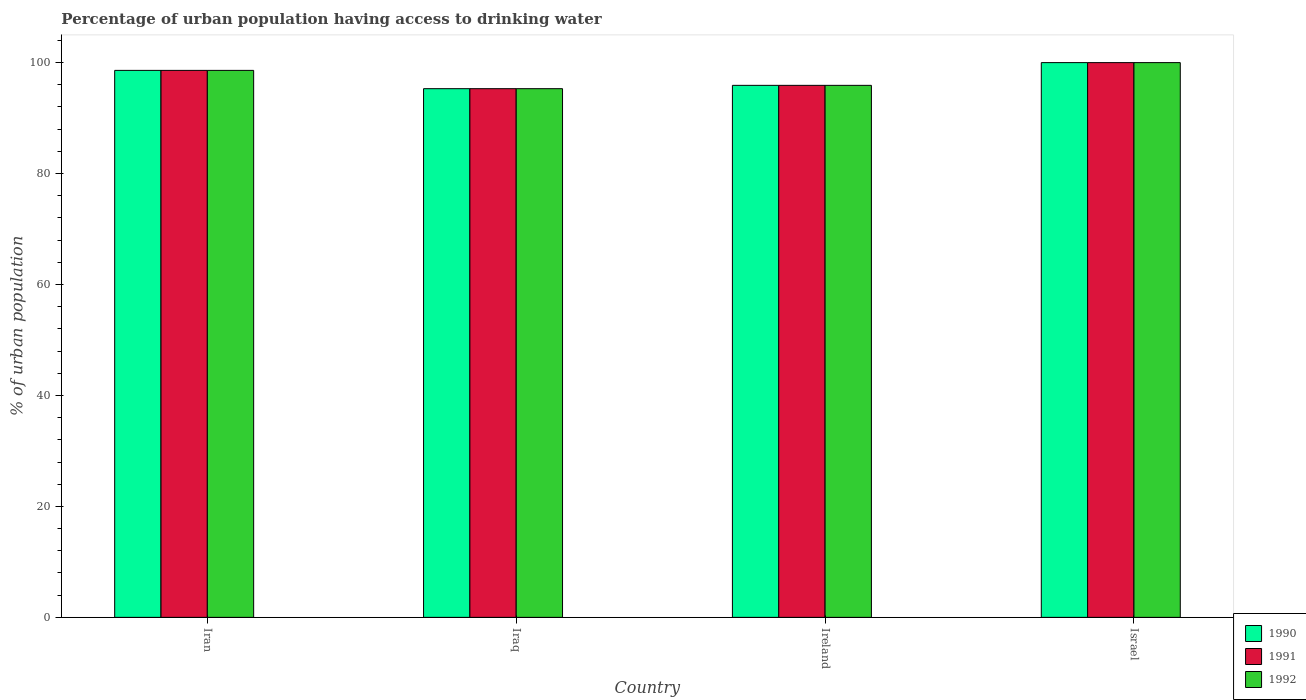How many different coloured bars are there?
Give a very brief answer. 3. How many groups of bars are there?
Your answer should be compact. 4. Are the number of bars per tick equal to the number of legend labels?
Ensure brevity in your answer.  Yes. Are the number of bars on each tick of the X-axis equal?
Offer a very short reply. Yes. How many bars are there on the 1st tick from the left?
Your response must be concise. 3. How many bars are there on the 4th tick from the right?
Offer a terse response. 3. What is the label of the 1st group of bars from the left?
Your response must be concise. Iran. In how many cases, is the number of bars for a given country not equal to the number of legend labels?
Make the answer very short. 0. What is the percentage of urban population having access to drinking water in 1990 in Ireland?
Your answer should be compact. 95.9. Across all countries, what is the maximum percentage of urban population having access to drinking water in 1990?
Make the answer very short. 100. Across all countries, what is the minimum percentage of urban population having access to drinking water in 1992?
Your answer should be compact. 95.3. In which country was the percentage of urban population having access to drinking water in 1991 minimum?
Provide a short and direct response. Iraq. What is the total percentage of urban population having access to drinking water in 1990 in the graph?
Provide a short and direct response. 389.8. What is the difference between the percentage of urban population having access to drinking water in 1990 in Ireland and that in Israel?
Make the answer very short. -4.1. What is the difference between the percentage of urban population having access to drinking water in 1990 in Iran and the percentage of urban population having access to drinking water in 1991 in Israel?
Provide a succinct answer. -1.4. What is the average percentage of urban population having access to drinking water in 1990 per country?
Offer a terse response. 97.45. What is the difference between the percentage of urban population having access to drinking water of/in 1992 and percentage of urban population having access to drinking water of/in 1991 in Israel?
Offer a terse response. 0. What is the ratio of the percentage of urban population having access to drinking water in 1990 in Iran to that in Ireland?
Offer a terse response. 1.03. Is the difference between the percentage of urban population having access to drinking water in 1992 in Iran and Israel greater than the difference between the percentage of urban population having access to drinking water in 1991 in Iran and Israel?
Make the answer very short. No. What is the difference between the highest and the second highest percentage of urban population having access to drinking water in 1992?
Ensure brevity in your answer.  -1.4. What is the difference between the highest and the lowest percentage of urban population having access to drinking water in 1992?
Provide a short and direct response. 4.7. In how many countries, is the percentage of urban population having access to drinking water in 1992 greater than the average percentage of urban population having access to drinking water in 1992 taken over all countries?
Your answer should be compact. 2. What does the 1st bar from the left in Iraq represents?
Make the answer very short. 1990. What does the 1st bar from the right in Iraq represents?
Keep it short and to the point. 1992. How many bars are there?
Give a very brief answer. 12. Are all the bars in the graph horizontal?
Your answer should be very brief. No. How many countries are there in the graph?
Provide a succinct answer. 4. Does the graph contain any zero values?
Offer a very short reply. No. Does the graph contain grids?
Make the answer very short. No. Where does the legend appear in the graph?
Offer a very short reply. Bottom right. What is the title of the graph?
Ensure brevity in your answer.  Percentage of urban population having access to drinking water. Does "2003" appear as one of the legend labels in the graph?
Ensure brevity in your answer.  No. What is the label or title of the X-axis?
Your answer should be compact. Country. What is the label or title of the Y-axis?
Your answer should be compact. % of urban population. What is the % of urban population in 1990 in Iran?
Provide a succinct answer. 98.6. What is the % of urban population of 1991 in Iran?
Your answer should be very brief. 98.6. What is the % of urban population of 1992 in Iran?
Keep it short and to the point. 98.6. What is the % of urban population in 1990 in Iraq?
Provide a short and direct response. 95.3. What is the % of urban population in 1991 in Iraq?
Offer a terse response. 95.3. What is the % of urban population of 1992 in Iraq?
Your answer should be very brief. 95.3. What is the % of urban population of 1990 in Ireland?
Provide a short and direct response. 95.9. What is the % of urban population of 1991 in Ireland?
Give a very brief answer. 95.9. What is the % of urban population in 1992 in Ireland?
Keep it short and to the point. 95.9. What is the % of urban population in 1990 in Israel?
Keep it short and to the point. 100. Across all countries, what is the maximum % of urban population in 1990?
Offer a terse response. 100. Across all countries, what is the minimum % of urban population in 1990?
Your answer should be compact. 95.3. Across all countries, what is the minimum % of urban population of 1991?
Your answer should be compact. 95.3. Across all countries, what is the minimum % of urban population in 1992?
Make the answer very short. 95.3. What is the total % of urban population in 1990 in the graph?
Your response must be concise. 389.8. What is the total % of urban population in 1991 in the graph?
Make the answer very short. 389.8. What is the total % of urban population in 1992 in the graph?
Offer a terse response. 389.8. What is the difference between the % of urban population in 1991 in Iran and that in Iraq?
Provide a succinct answer. 3.3. What is the difference between the % of urban population in 1992 in Iran and that in Ireland?
Give a very brief answer. 2.7. What is the difference between the % of urban population of 1990 in Iraq and that in Ireland?
Ensure brevity in your answer.  -0.6. What is the difference between the % of urban population in 1992 in Iraq and that in Ireland?
Your answer should be compact. -0.6. What is the difference between the % of urban population in 1990 in Iraq and that in Israel?
Your answer should be very brief. -4.7. What is the difference between the % of urban population of 1991 in Iraq and that in Israel?
Keep it short and to the point. -4.7. What is the difference between the % of urban population in 1990 in Ireland and that in Israel?
Ensure brevity in your answer.  -4.1. What is the difference between the % of urban population in 1992 in Ireland and that in Israel?
Provide a short and direct response. -4.1. What is the difference between the % of urban population in 1990 in Iran and the % of urban population in 1991 in Iraq?
Make the answer very short. 3.3. What is the difference between the % of urban population in 1991 in Iran and the % of urban population in 1992 in Iraq?
Provide a short and direct response. 3.3. What is the difference between the % of urban population in 1990 in Iran and the % of urban population in 1991 in Ireland?
Provide a short and direct response. 2.7. What is the difference between the % of urban population in 1990 in Iran and the % of urban population in 1992 in Ireland?
Your answer should be compact. 2.7. What is the difference between the % of urban population in 1991 in Iran and the % of urban population in 1992 in Israel?
Make the answer very short. -1.4. What is the difference between the % of urban population in 1990 in Iraq and the % of urban population in 1991 in Ireland?
Your response must be concise. -0.6. What is the difference between the % of urban population in 1990 in Iraq and the % of urban population in 1992 in Ireland?
Ensure brevity in your answer.  -0.6. What is the difference between the % of urban population in 1991 in Iraq and the % of urban population in 1992 in Ireland?
Ensure brevity in your answer.  -0.6. What is the difference between the % of urban population in 1990 in Iraq and the % of urban population in 1991 in Israel?
Offer a very short reply. -4.7. What is the difference between the % of urban population in 1991 in Iraq and the % of urban population in 1992 in Israel?
Provide a short and direct response. -4.7. What is the difference between the % of urban population in 1990 in Ireland and the % of urban population in 1991 in Israel?
Your response must be concise. -4.1. What is the difference between the % of urban population in 1990 in Ireland and the % of urban population in 1992 in Israel?
Your response must be concise. -4.1. What is the difference between the % of urban population of 1991 in Ireland and the % of urban population of 1992 in Israel?
Offer a very short reply. -4.1. What is the average % of urban population of 1990 per country?
Keep it short and to the point. 97.45. What is the average % of urban population of 1991 per country?
Provide a succinct answer. 97.45. What is the average % of urban population of 1992 per country?
Provide a succinct answer. 97.45. What is the difference between the % of urban population of 1990 and % of urban population of 1992 in Iran?
Ensure brevity in your answer.  0. What is the difference between the % of urban population in 1991 and % of urban population in 1992 in Iran?
Your answer should be compact. 0. What is the difference between the % of urban population of 1990 and % of urban population of 1991 in Iraq?
Offer a terse response. 0. What is the difference between the % of urban population of 1990 and % of urban population of 1991 in Ireland?
Provide a short and direct response. 0. What is the difference between the % of urban population of 1990 and % of urban population of 1992 in Ireland?
Provide a short and direct response. 0. What is the difference between the % of urban population of 1991 and % of urban population of 1992 in Ireland?
Provide a succinct answer. 0. What is the difference between the % of urban population of 1990 and % of urban population of 1991 in Israel?
Offer a terse response. 0. What is the difference between the % of urban population of 1991 and % of urban population of 1992 in Israel?
Your response must be concise. 0. What is the ratio of the % of urban population of 1990 in Iran to that in Iraq?
Your response must be concise. 1.03. What is the ratio of the % of urban population of 1991 in Iran to that in Iraq?
Make the answer very short. 1.03. What is the ratio of the % of urban population in 1992 in Iran to that in Iraq?
Offer a very short reply. 1.03. What is the ratio of the % of urban population in 1990 in Iran to that in Ireland?
Provide a succinct answer. 1.03. What is the ratio of the % of urban population in 1991 in Iran to that in Ireland?
Your answer should be very brief. 1.03. What is the ratio of the % of urban population of 1992 in Iran to that in Ireland?
Provide a short and direct response. 1.03. What is the ratio of the % of urban population in 1990 in Iran to that in Israel?
Offer a terse response. 0.99. What is the ratio of the % of urban population in 1992 in Iran to that in Israel?
Your answer should be compact. 0.99. What is the ratio of the % of urban population in 1991 in Iraq to that in Ireland?
Provide a succinct answer. 0.99. What is the ratio of the % of urban population in 1990 in Iraq to that in Israel?
Ensure brevity in your answer.  0.95. What is the ratio of the % of urban population in 1991 in Iraq to that in Israel?
Your response must be concise. 0.95. What is the ratio of the % of urban population in 1992 in Iraq to that in Israel?
Your response must be concise. 0.95. What is the ratio of the % of urban population of 1990 in Ireland to that in Israel?
Offer a very short reply. 0.96. What is the ratio of the % of urban population of 1991 in Ireland to that in Israel?
Your answer should be compact. 0.96. What is the ratio of the % of urban population in 1992 in Ireland to that in Israel?
Keep it short and to the point. 0.96. What is the difference between the highest and the second highest % of urban population in 1992?
Offer a very short reply. 1.4. What is the difference between the highest and the lowest % of urban population in 1991?
Provide a short and direct response. 4.7. What is the difference between the highest and the lowest % of urban population in 1992?
Offer a terse response. 4.7. 